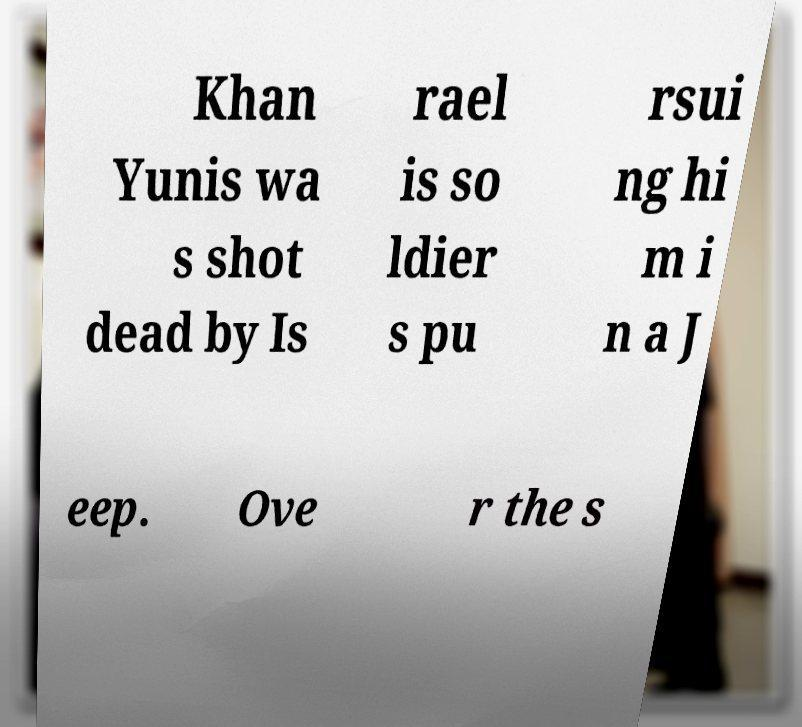What messages or text are displayed in this image? I need them in a readable, typed format. Khan Yunis wa s shot dead by Is rael is so ldier s pu rsui ng hi m i n a J eep. Ove r the s 